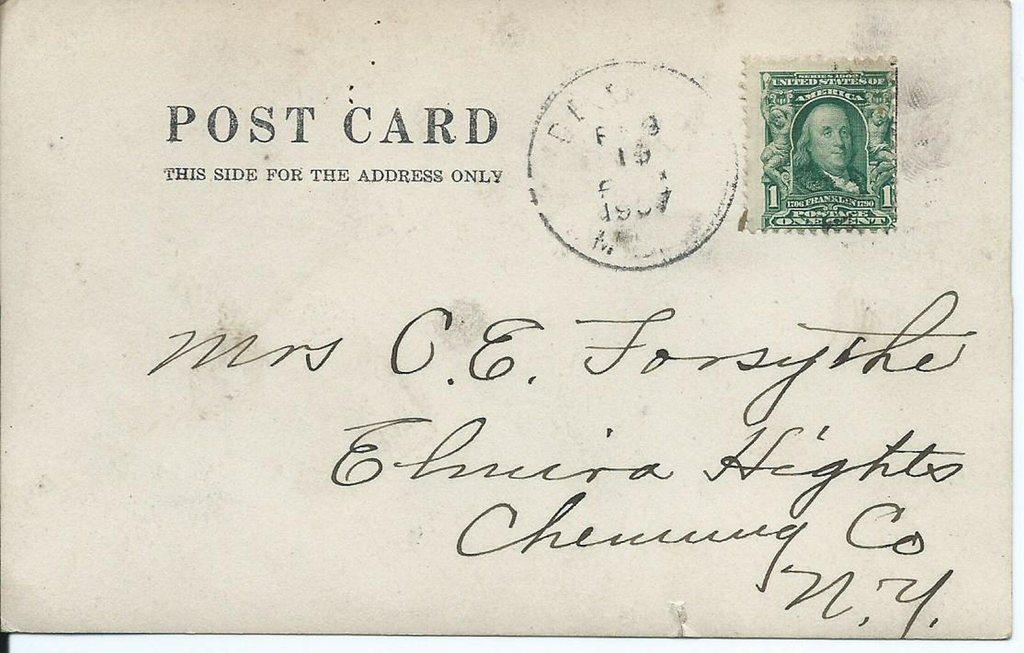<image>
Relay a brief, clear account of the picture shown. A post card addressed to Mrs. C. E. Forsythe of Chemung County, New York 